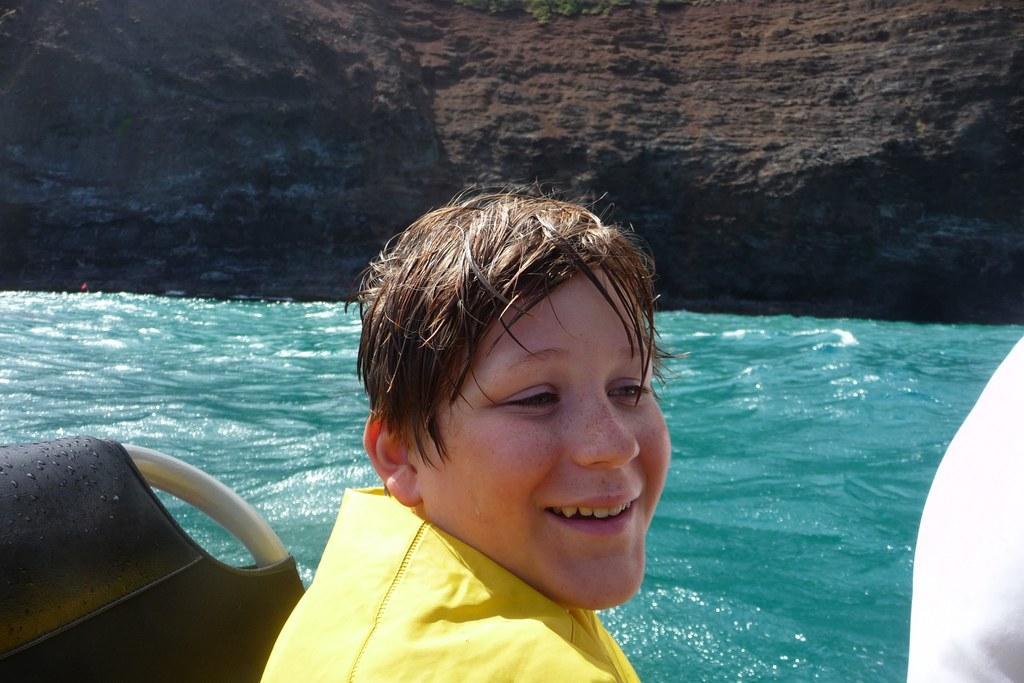Please provide a concise description of this image. As we can see in the image there is a boy wearing yellow color t shirt and sitting on boat. There is water and hill. 